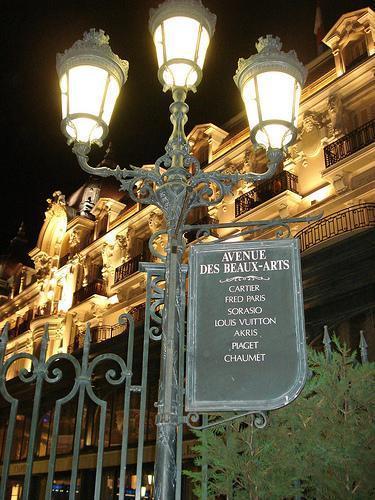How many lights are on the pole?
Give a very brief answer. 3. 